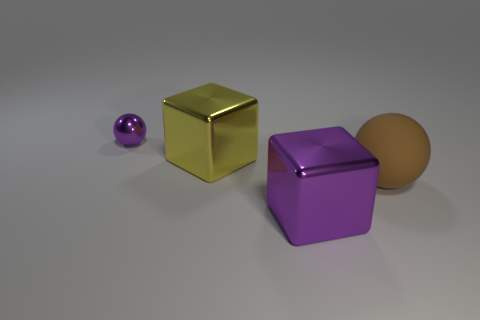Add 3 big purple metal things. How many objects exist? 7 Add 2 tiny green cylinders. How many tiny green cylinders exist? 2 Subtract 0 blue balls. How many objects are left? 4 Subtract all cyan things. Subtract all purple spheres. How many objects are left? 3 Add 3 large matte things. How many large matte things are left? 4 